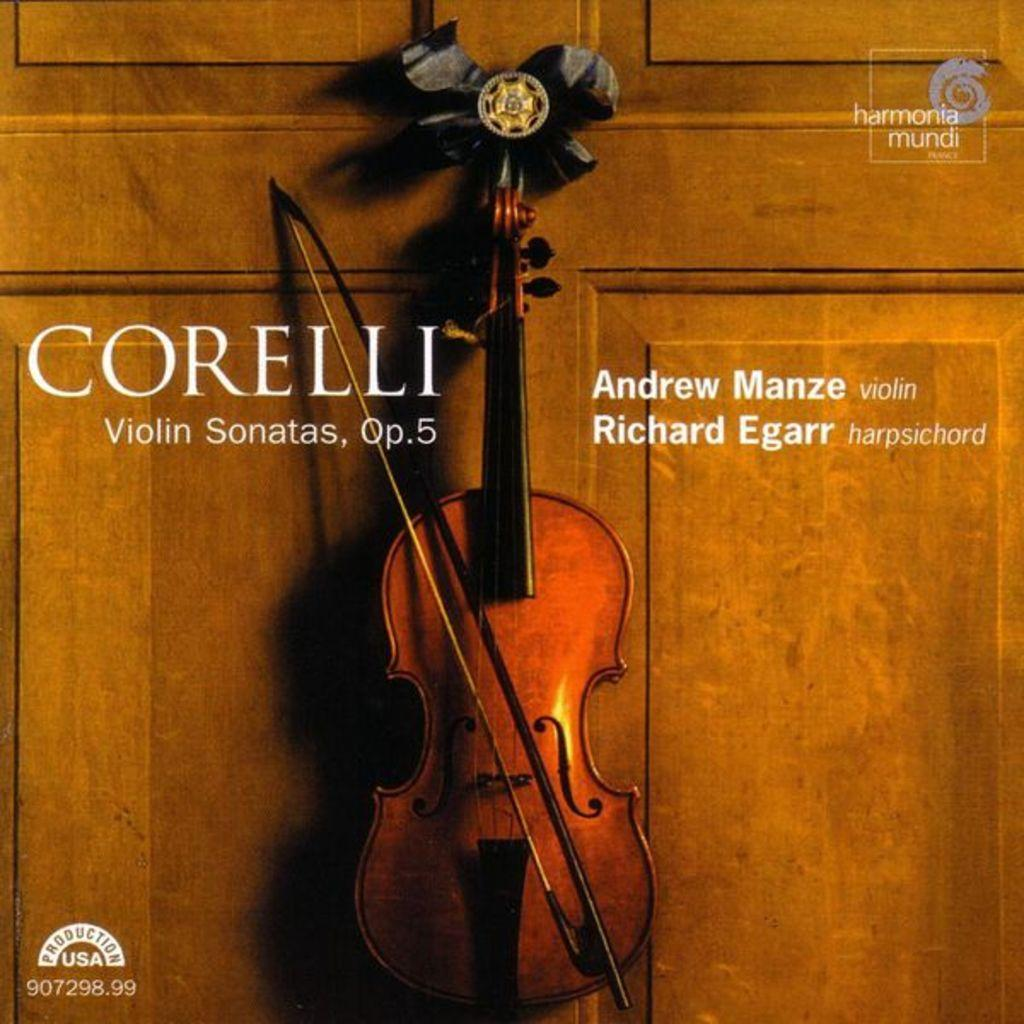What is depicted on the poster in the image? The poster features a violin. What name is written on the poster? The name "CORELLI" is written on the poster. Who is associated with the violin on the poster? The name "andrew manze" is associated with the violin on the poster. What type of lettuce is being used as a prop in the image? There is no lettuce present in the image; it features a poster with a violin and names associated with it. 